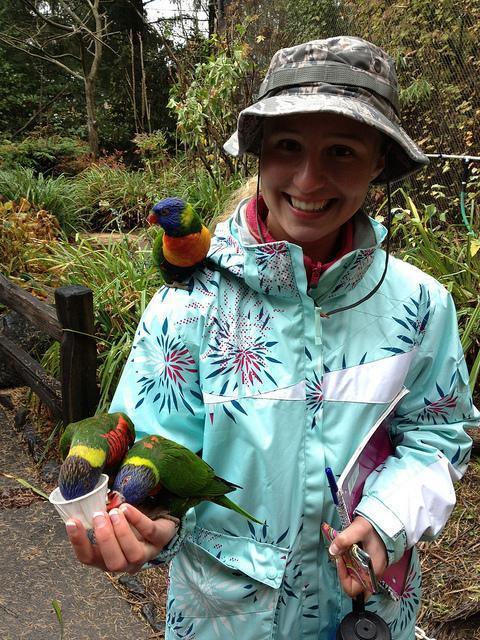How many birds are there?
Give a very brief answer. 3. 